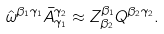Convert formula to latex. <formula><loc_0><loc_0><loc_500><loc_500>\hat { \omega } ^ { \beta _ { 1 } \gamma _ { 1 } } \bar { A } _ { \gamma _ { 1 } } ^ { \gamma _ { 2 } } \approx Z _ { \beta _ { 2 } } ^ { \beta _ { 1 } } Q ^ { \beta _ { 2 } \gamma _ { 2 } } .</formula> 